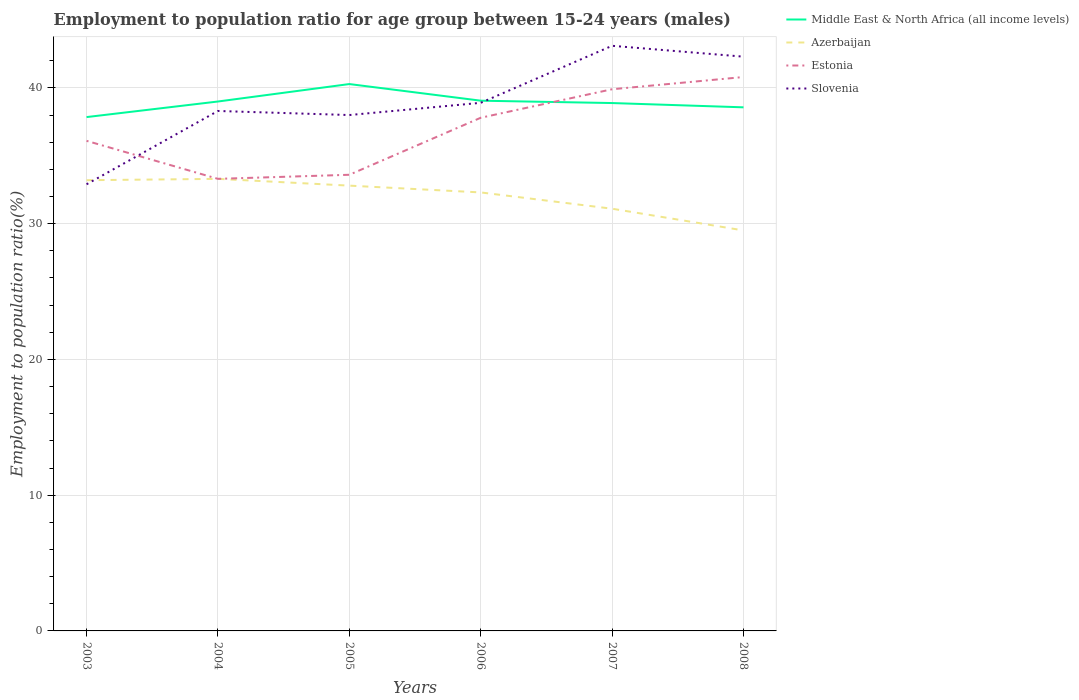Does the line corresponding to Azerbaijan intersect with the line corresponding to Slovenia?
Your answer should be very brief. Yes. Is the number of lines equal to the number of legend labels?
Your response must be concise. Yes. Across all years, what is the maximum employment to population ratio in Azerbaijan?
Your response must be concise. 29.5. In which year was the employment to population ratio in Slovenia maximum?
Ensure brevity in your answer.  2003. What is the total employment to population ratio in Slovenia in the graph?
Keep it short and to the point. -6. What is the difference between the highest and the second highest employment to population ratio in Estonia?
Your response must be concise. 7.5. What is the difference between the highest and the lowest employment to population ratio in Slovenia?
Give a very brief answer. 2. How many lines are there?
Provide a short and direct response. 4. How many years are there in the graph?
Your answer should be very brief. 6. What is the difference between two consecutive major ticks on the Y-axis?
Offer a terse response. 10. How are the legend labels stacked?
Make the answer very short. Vertical. What is the title of the graph?
Offer a very short reply. Employment to population ratio for age group between 15-24 years (males). What is the label or title of the X-axis?
Provide a succinct answer. Years. What is the label or title of the Y-axis?
Ensure brevity in your answer.  Employment to population ratio(%). What is the Employment to population ratio(%) in Middle East & North Africa (all income levels) in 2003?
Offer a very short reply. 37.85. What is the Employment to population ratio(%) of Azerbaijan in 2003?
Offer a terse response. 33.2. What is the Employment to population ratio(%) of Estonia in 2003?
Offer a terse response. 36.1. What is the Employment to population ratio(%) of Slovenia in 2003?
Offer a terse response. 32.9. What is the Employment to population ratio(%) of Middle East & North Africa (all income levels) in 2004?
Provide a succinct answer. 39. What is the Employment to population ratio(%) of Azerbaijan in 2004?
Provide a short and direct response. 33.3. What is the Employment to population ratio(%) in Estonia in 2004?
Offer a very short reply. 33.3. What is the Employment to population ratio(%) of Slovenia in 2004?
Provide a short and direct response. 38.3. What is the Employment to population ratio(%) in Middle East & North Africa (all income levels) in 2005?
Ensure brevity in your answer.  40.28. What is the Employment to population ratio(%) in Azerbaijan in 2005?
Keep it short and to the point. 32.8. What is the Employment to population ratio(%) in Estonia in 2005?
Your answer should be very brief. 33.6. What is the Employment to population ratio(%) in Middle East & North Africa (all income levels) in 2006?
Keep it short and to the point. 39.06. What is the Employment to population ratio(%) of Azerbaijan in 2006?
Ensure brevity in your answer.  32.3. What is the Employment to population ratio(%) in Estonia in 2006?
Give a very brief answer. 37.8. What is the Employment to population ratio(%) of Slovenia in 2006?
Offer a very short reply. 38.9. What is the Employment to population ratio(%) of Middle East & North Africa (all income levels) in 2007?
Your answer should be compact. 38.88. What is the Employment to population ratio(%) in Azerbaijan in 2007?
Provide a succinct answer. 31.1. What is the Employment to population ratio(%) in Estonia in 2007?
Make the answer very short. 39.9. What is the Employment to population ratio(%) of Slovenia in 2007?
Keep it short and to the point. 43.1. What is the Employment to population ratio(%) of Middle East & North Africa (all income levels) in 2008?
Your answer should be very brief. 38.57. What is the Employment to population ratio(%) in Azerbaijan in 2008?
Give a very brief answer. 29.5. What is the Employment to population ratio(%) in Estonia in 2008?
Give a very brief answer. 40.8. What is the Employment to population ratio(%) in Slovenia in 2008?
Your answer should be very brief. 42.3. Across all years, what is the maximum Employment to population ratio(%) in Middle East & North Africa (all income levels)?
Offer a very short reply. 40.28. Across all years, what is the maximum Employment to population ratio(%) of Azerbaijan?
Offer a very short reply. 33.3. Across all years, what is the maximum Employment to population ratio(%) of Estonia?
Your answer should be compact. 40.8. Across all years, what is the maximum Employment to population ratio(%) in Slovenia?
Keep it short and to the point. 43.1. Across all years, what is the minimum Employment to population ratio(%) in Middle East & North Africa (all income levels)?
Your answer should be compact. 37.85. Across all years, what is the minimum Employment to population ratio(%) of Azerbaijan?
Your response must be concise. 29.5. Across all years, what is the minimum Employment to population ratio(%) of Estonia?
Provide a succinct answer. 33.3. Across all years, what is the minimum Employment to population ratio(%) in Slovenia?
Make the answer very short. 32.9. What is the total Employment to population ratio(%) of Middle East & North Africa (all income levels) in the graph?
Your answer should be compact. 233.64. What is the total Employment to population ratio(%) of Azerbaijan in the graph?
Offer a very short reply. 192.2. What is the total Employment to population ratio(%) in Estonia in the graph?
Your answer should be very brief. 221.5. What is the total Employment to population ratio(%) of Slovenia in the graph?
Provide a short and direct response. 233.5. What is the difference between the Employment to population ratio(%) in Middle East & North Africa (all income levels) in 2003 and that in 2004?
Your response must be concise. -1.15. What is the difference between the Employment to population ratio(%) in Azerbaijan in 2003 and that in 2004?
Provide a succinct answer. -0.1. What is the difference between the Employment to population ratio(%) of Estonia in 2003 and that in 2004?
Your answer should be very brief. 2.8. What is the difference between the Employment to population ratio(%) in Slovenia in 2003 and that in 2004?
Your answer should be compact. -5.4. What is the difference between the Employment to population ratio(%) in Middle East & North Africa (all income levels) in 2003 and that in 2005?
Your answer should be compact. -2.43. What is the difference between the Employment to population ratio(%) of Azerbaijan in 2003 and that in 2005?
Make the answer very short. 0.4. What is the difference between the Employment to population ratio(%) of Middle East & North Africa (all income levels) in 2003 and that in 2006?
Give a very brief answer. -1.21. What is the difference between the Employment to population ratio(%) in Estonia in 2003 and that in 2006?
Provide a short and direct response. -1.7. What is the difference between the Employment to population ratio(%) of Slovenia in 2003 and that in 2006?
Your answer should be compact. -6. What is the difference between the Employment to population ratio(%) of Middle East & North Africa (all income levels) in 2003 and that in 2007?
Keep it short and to the point. -1.03. What is the difference between the Employment to population ratio(%) in Estonia in 2003 and that in 2007?
Make the answer very short. -3.8. What is the difference between the Employment to population ratio(%) of Slovenia in 2003 and that in 2007?
Your answer should be very brief. -10.2. What is the difference between the Employment to population ratio(%) in Middle East & North Africa (all income levels) in 2003 and that in 2008?
Offer a terse response. -0.72. What is the difference between the Employment to population ratio(%) of Estonia in 2003 and that in 2008?
Make the answer very short. -4.7. What is the difference between the Employment to population ratio(%) of Slovenia in 2003 and that in 2008?
Offer a very short reply. -9.4. What is the difference between the Employment to population ratio(%) in Middle East & North Africa (all income levels) in 2004 and that in 2005?
Provide a succinct answer. -1.29. What is the difference between the Employment to population ratio(%) in Middle East & North Africa (all income levels) in 2004 and that in 2006?
Ensure brevity in your answer.  -0.06. What is the difference between the Employment to population ratio(%) in Azerbaijan in 2004 and that in 2006?
Keep it short and to the point. 1. What is the difference between the Employment to population ratio(%) in Slovenia in 2004 and that in 2006?
Keep it short and to the point. -0.6. What is the difference between the Employment to population ratio(%) in Middle East & North Africa (all income levels) in 2004 and that in 2007?
Offer a very short reply. 0.11. What is the difference between the Employment to population ratio(%) in Azerbaijan in 2004 and that in 2007?
Your answer should be compact. 2.2. What is the difference between the Employment to population ratio(%) in Estonia in 2004 and that in 2007?
Your answer should be very brief. -6.6. What is the difference between the Employment to population ratio(%) in Middle East & North Africa (all income levels) in 2004 and that in 2008?
Ensure brevity in your answer.  0.43. What is the difference between the Employment to population ratio(%) of Estonia in 2004 and that in 2008?
Offer a terse response. -7.5. What is the difference between the Employment to population ratio(%) of Slovenia in 2004 and that in 2008?
Give a very brief answer. -4. What is the difference between the Employment to population ratio(%) in Middle East & North Africa (all income levels) in 2005 and that in 2006?
Give a very brief answer. 1.23. What is the difference between the Employment to population ratio(%) of Azerbaijan in 2005 and that in 2006?
Offer a terse response. 0.5. What is the difference between the Employment to population ratio(%) of Slovenia in 2005 and that in 2006?
Offer a terse response. -0.9. What is the difference between the Employment to population ratio(%) of Middle East & North Africa (all income levels) in 2005 and that in 2007?
Give a very brief answer. 1.4. What is the difference between the Employment to population ratio(%) in Azerbaijan in 2005 and that in 2007?
Ensure brevity in your answer.  1.7. What is the difference between the Employment to population ratio(%) of Slovenia in 2005 and that in 2007?
Ensure brevity in your answer.  -5.1. What is the difference between the Employment to population ratio(%) in Middle East & North Africa (all income levels) in 2005 and that in 2008?
Your response must be concise. 1.72. What is the difference between the Employment to population ratio(%) in Azerbaijan in 2005 and that in 2008?
Keep it short and to the point. 3.3. What is the difference between the Employment to population ratio(%) in Estonia in 2005 and that in 2008?
Provide a succinct answer. -7.2. What is the difference between the Employment to population ratio(%) of Slovenia in 2005 and that in 2008?
Give a very brief answer. -4.3. What is the difference between the Employment to population ratio(%) in Middle East & North Africa (all income levels) in 2006 and that in 2007?
Provide a succinct answer. 0.17. What is the difference between the Employment to population ratio(%) of Azerbaijan in 2006 and that in 2007?
Give a very brief answer. 1.2. What is the difference between the Employment to population ratio(%) of Estonia in 2006 and that in 2007?
Offer a very short reply. -2.1. What is the difference between the Employment to population ratio(%) of Slovenia in 2006 and that in 2007?
Offer a very short reply. -4.2. What is the difference between the Employment to population ratio(%) of Middle East & North Africa (all income levels) in 2006 and that in 2008?
Make the answer very short. 0.49. What is the difference between the Employment to population ratio(%) in Azerbaijan in 2006 and that in 2008?
Offer a very short reply. 2.8. What is the difference between the Employment to population ratio(%) in Middle East & North Africa (all income levels) in 2007 and that in 2008?
Your response must be concise. 0.32. What is the difference between the Employment to population ratio(%) in Azerbaijan in 2007 and that in 2008?
Provide a short and direct response. 1.6. What is the difference between the Employment to population ratio(%) of Estonia in 2007 and that in 2008?
Your answer should be very brief. -0.9. What is the difference between the Employment to population ratio(%) in Middle East & North Africa (all income levels) in 2003 and the Employment to population ratio(%) in Azerbaijan in 2004?
Keep it short and to the point. 4.55. What is the difference between the Employment to population ratio(%) of Middle East & North Africa (all income levels) in 2003 and the Employment to population ratio(%) of Estonia in 2004?
Your answer should be compact. 4.55. What is the difference between the Employment to population ratio(%) in Middle East & North Africa (all income levels) in 2003 and the Employment to population ratio(%) in Slovenia in 2004?
Make the answer very short. -0.45. What is the difference between the Employment to population ratio(%) in Azerbaijan in 2003 and the Employment to population ratio(%) in Estonia in 2004?
Offer a terse response. -0.1. What is the difference between the Employment to population ratio(%) in Estonia in 2003 and the Employment to population ratio(%) in Slovenia in 2004?
Provide a succinct answer. -2.2. What is the difference between the Employment to population ratio(%) in Middle East & North Africa (all income levels) in 2003 and the Employment to population ratio(%) in Azerbaijan in 2005?
Make the answer very short. 5.05. What is the difference between the Employment to population ratio(%) in Middle East & North Africa (all income levels) in 2003 and the Employment to population ratio(%) in Estonia in 2005?
Provide a succinct answer. 4.25. What is the difference between the Employment to population ratio(%) of Middle East & North Africa (all income levels) in 2003 and the Employment to population ratio(%) of Slovenia in 2005?
Make the answer very short. -0.15. What is the difference between the Employment to population ratio(%) of Azerbaijan in 2003 and the Employment to population ratio(%) of Slovenia in 2005?
Provide a short and direct response. -4.8. What is the difference between the Employment to population ratio(%) of Estonia in 2003 and the Employment to population ratio(%) of Slovenia in 2005?
Keep it short and to the point. -1.9. What is the difference between the Employment to population ratio(%) in Middle East & North Africa (all income levels) in 2003 and the Employment to population ratio(%) in Azerbaijan in 2006?
Your response must be concise. 5.55. What is the difference between the Employment to population ratio(%) in Middle East & North Africa (all income levels) in 2003 and the Employment to population ratio(%) in Estonia in 2006?
Give a very brief answer. 0.05. What is the difference between the Employment to population ratio(%) of Middle East & North Africa (all income levels) in 2003 and the Employment to population ratio(%) of Slovenia in 2006?
Offer a very short reply. -1.05. What is the difference between the Employment to population ratio(%) of Azerbaijan in 2003 and the Employment to population ratio(%) of Estonia in 2006?
Give a very brief answer. -4.6. What is the difference between the Employment to population ratio(%) in Azerbaijan in 2003 and the Employment to population ratio(%) in Slovenia in 2006?
Your answer should be very brief. -5.7. What is the difference between the Employment to population ratio(%) in Estonia in 2003 and the Employment to population ratio(%) in Slovenia in 2006?
Give a very brief answer. -2.8. What is the difference between the Employment to population ratio(%) in Middle East & North Africa (all income levels) in 2003 and the Employment to population ratio(%) in Azerbaijan in 2007?
Ensure brevity in your answer.  6.75. What is the difference between the Employment to population ratio(%) of Middle East & North Africa (all income levels) in 2003 and the Employment to population ratio(%) of Estonia in 2007?
Provide a short and direct response. -2.05. What is the difference between the Employment to population ratio(%) in Middle East & North Africa (all income levels) in 2003 and the Employment to population ratio(%) in Slovenia in 2007?
Your response must be concise. -5.25. What is the difference between the Employment to population ratio(%) in Middle East & North Africa (all income levels) in 2003 and the Employment to population ratio(%) in Azerbaijan in 2008?
Your answer should be very brief. 8.35. What is the difference between the Employment to population ratio(%) of Middle East & North Africa (all income levels) in 2003 and the Employment to population ratio(%) of Estonia in 2008?
Your answer should be compact. -2.95. What is the difference between the Employment to population ratio(%) of Middle East & North Africa (all income levels) in 2003 and the Employment to population ratio(%) of Slovenia in 2008?
Your response must be concise. -4.45. What is the difference between the Employment to population ratio(%) of Azerbaijan in 2003 and the Employment to population ratio(%) of Estonia in 2008?
Ensure brevity in your answer.  -7.6. What is the difference between the Employment to population ratio(%) in Middle East & North Africa (all income levels) in 2004 and the Employment to population ratio(%) in Azerbaijan in 2005?
Make the answer very short. 6.2. What is the difference between the Employment to population ratio(%) in Middle East & North Africa (all income levels) in 2004 and the Employment to population ratio(%) in Estonia in 2005?
Provide a succinct answer. 5.4. What is the difference between the Employment to population ratio(%) of Middle East & North Africa (all income levels) in 2004 and the Employment to population ratio(%) of Slovenia in 2005?
Keep it short and to the point. 1. What is the difference between the Employment to population ratio(%) of Azerbaijan in 2004 and the Employment to population ratio(%) of Slovenia in 2005?
Offer a very short reply. -4.7. What is the difference between the Employment to population ratio(%) of Estonia in 2004 and the Employment to population ratio(%) of Slovenia in 2005?
Make the answer very short. -4.7. What is the difference between the Employment to population ratio(%) in Middle East & North Africa (all income levels) in 2004 and the Employment to population ratio(%) in Azerbaijan in 2006?
Give a very brief answer. 6.7. What is the difference between the Employment to population ratio(%) of Middle East & North Africa (all income levels) in 2004 and the Employment to population ratio(%) of Estonia in 2006?
Your answer should be very brief. 1.2. What is the difference between the Employment to population ratio(%) of Middle East & North Africa (all income levels) in 2004 and the Employment to population ratio(%) of Slovenia in 2006?
Ensure brevity in your answer.  0.1. What is the difference between the Employment to population ratio(%) in Azerbaijan in 2004 and the Employment to population ratio(%) in Estonia in 2006?
Ensure brevity in your answer.  -4.5. What is the difference between the Employment to population ratio(%) of Azerbaijan in 2004 and the Employment to population ratio(%) of Slovenia in 2006?
Provide a succinct answer. -5.6. What is the difference between the Employment to population ratio(%) in Middle East & North Africa (all income levels) in 2004 and the Employment to population ratio(%) in Azerbaijan in 2007?
Ensure brevity in your answer.  7.9. What is the difference between the Employment to population ratio(%) of Middle East & North Africa (all income levels) in 2004 and the Employment to population ratio(%) of Estonia in 2007?
Keep it short and to the point. -0.9. What is the difference between the Employment to population ratio(%) in Middle East & North Africa (all income levels) in 2004 and the Employment to population ratio(%) in Slovenia in 2007?
Give a very brief answer. -4.1. What is the difference between the Employment to population ratio(%) of Azerbaijan in 2004 and the Employment to population ratio(%) of Estonia in 2007?
Make the answer very short. -6.6. What is the difference between the Employment to population ratio(%) of Estonia in 2004 and the Employment to population ratio(%) of Slovenia in 2007?
Your response must be concise. -9.8. What is the difference between the Employment to population ratio(%) in Middle East & North Africa (all income levels) in 2004 and the Employment to population ratio(%) in Azerbaijan in 2008?
Your response must be concise. 9.5. What is the difference between the Employment to population ratio(%) in Middle East & North Africa (all income levels) in 2004 and the Employment to population ratio(%) in Estonia in 2008?
Give a very brief answer. -1.8. What is the difference between the Employment to population ratio(%) of Middle East & North Africa (all income levels) in 2004 and the Employment to population ratio(%) of Slovenia in 2008?
Your answer should be compact. -3.3. What is the difference between the Employment to population ratio(%) of Azerbaijan in 2004 and the Employment to population ratio(%) of Slovenia in 2008?
Make the answer very short. -9. What is the difference between the Employment to population ratio(%) of Middle East & North Africa (all income levels) in 2005 and the Employment to population ratio(%) of Azerbaijan in 2006?
Make the answer very short. 7.98. What is the difference between the Employment to population ratio(%) of Middle East & North Africa (all income levels) in 2005 and the Employment to population ratio(%) of Estonia in 2006?
Provide a succinct answer. 2.48. What is the difference between the Employment to population ratio(%) in Middle East & North Africa (all income levels) in 2005 and the Employment to population ratio(%) in Slovenia in 2006?
Provide a succinct answer. 1.38. What is the difference between the Employment to population ratio(%) of Azerbaijan in 2005 and the Employment to population ratio(%) of Estonia in 2006?
Your answer should be compact. -5. What is the difference between the Employment to population ratio(%) in Estonia in 2005 and the Employment to population ratio(%) in Slovenia in 2006?
Your response must be concise. -5.3. What is the difference between the Employment to population ratio(%) of Middle East & North Africa (all income levels) in 2005 and the Employment to population ratio(%) of Azerbaijan in 2007?
Provide a short and direct response. 9.18. What is the difference between the Employment to population ratio(%) of Middle East & North Africa (all income levels) in 2005 and the Employment to population ratio(%) of Estonia in 2007?
Provide a succinct answer. 0.38. What is the difference between the Employment to population ratio(%) of Middle East & North Africa (all income levels) in 2005 and the Employment to population ratio(%) of Slovenia in 2007?
Your answer should be very brief. -2.82. What is the difference between the Employment to population ratio(%) in Middle East & North Africa (all income levels) in 2005 and the Employment to population ratio(%) in Azerbaijan in 2008?
Make the answer very short. 10.78. What is the difference between the Employment to population ratio(%) of Middle East & North Africa (all income levels) in 2005 and the Employment to population ratio(%) of Estonia in 2008?
Your answer should be very brief. -0.52. What is the difference between the Employment to population ratio(%) of Middle East & North Africa (all income levels) in 2005 and the Employment to population ratio(%) of Slovenia in 2008?
Your answer should be compact. -2.02. What is the difference between the Employment to population ratio(%) in Middle East & North Africa (all income levels) in 2006 and the Employment to population ratio(%) in Azerbaijan in 2007?
Offer a very short reply. 7.96. What is the difference between the Employment to population ratio(%) in Middle East & North Africa (all income levels) in 2006 and the Employment to population ratio(%) in Estonia in 2007?
Your answer should be very brief. -0.84. What is the difference between the Employment to population ratio(%) in Middle East & North Africa (all income levels) in 2006 and the Employment to population ratio(%) in Slovenia in 2007?
Give a very brief answer. -4.04. What is the difference between the Employment to population ratio(%) of Azerbaijan in 2006 and the Employment to population ratio(%) of Estonia in 2007?
Keep it short and to the point. -7.6. What is the difference between the Employment to population ratio(%) of Estonia in 2006 and the Employment to population ratio(%) of Slovenia in 2007?
Ensure brevity in your answer.  -5.3. What is the difference between the Employment to population ratio(%) in Middle East & North Africa (all income levels) in 2006 and the Employment to population ratio(%) in Azerbaijan in 2008?
Your answer should be compact. 9.56. What is the difference between the Employment to population ratio(%) of Middle East & North Africa (all income levels) in 2006 and the Employment to population ratio(%) of Estonia in 2008?
Offer a terse response. -1.74. What is the difference between the Employment to population ratio(%) of Middle East & North Africa (all income levels) in 2006 and the Employment to population ratio(%) of Slovenia in 2008?
Offer a very short reply. -3.24. What is the difference between the Employment to population ratio(%) of Azerbaijan in 2006 and the Employment to population ratio(%) of Estonia in 2008?
Offer a terse response. -8.5. What is the difference between the Employment to population ratio(%) in Middle East & North Africa (all income levels) in 2007 and the Employment to population ratio(%) in Azerbaijan in 2008?
Your answer should be very brief. 9.38. What is the difference between the Employment to population ratio(%) in Middle East & North Africa (all income levels) in 2007 and the Employment to population ratio(%) in Estonia in 2008?
Ensure brevity in your answer.  -1.92. What is the difference between the Employment to population ratio(%) of Middle East & North Africa (all income levels) in 2007 and the Employment to population ratio(%) of Slovenia in 2008?
Provide a short and direct response. -3.42. What is the average Employment to population ratio(%) of Middle East & North Africa (all income levels) per year?
Keep it short and to the point. 38.94. What is the average Employment to population ratio(%) in Azerbaijan per year?
Give a very brief answer. 32.03. What is the average Employment to population ratio(%) of Estonia per year?
Keep it short and to the point. 36.92. What is the average Employment to population ratio(%) of Slovenia per year?
Provide a short and direct response. 38.92. In the year 2003, what is the difference between the Employment to population ratio(%) in Middle East & North Africa (all income levels) and Employment to population ratio(%) in Azerbaijan?
Offer a very short reply. 4.65. In the year 2003, what is the difference between the Employment to population ratio(%) in Middle East & North Africa (all income levels) and Employment to population ratio(%) in Estonia?
Offer a terse response. 1.75. In the year 2003, what is the difference between the Employment to population ratio(%) of Middle East & North Africa (all income levels) and Employment to population ratio(%) of Slovenia?
Your answer should be very brief. 4.95. In the year 2004, what is the difference between the Employment to population ratio(%) of Middle East & North Africa (all income levels) and Employment to population ratio(%) of Azerbaijan?
Offer a very short reply. 5.7. In the year 2004, what is the difference between the Employment to population ratio(%) in Middle East & North Africa (all income levels) and Employment to population ratio(%) in Estonia?
Your answer should be very brief. 5.7. In the year 2004, what is the difference between the Employment to population ratio(%) of Middle East & North Africa (all income levels) and Employment to population ratio(%) of Slovenia?
Your answer should be compact. 0.7. In the year 2004, what is the difference between the Employment to population ratio(%) in Azerbaijan and Employment to population ratio(%) in Estonia?
Provide a succinct answer. 0. In the year 2004, what is the difference between the Employment to population ratio(%) in Azerbaijan and Employment to population ratio(%) in Slovenia?
Offer a terse response. -5. In the year 2005, what is the difference between the Employment to population ratio(%) in Middle East & North Africa (all income levels) and Employment to population ratio(%) in Azerbaijan?
Your answer should be very brief. 7.48. In the year 2005, what is the difference between the Employment to population ratio(%) of Middle East & North Africa (all income levels) and Employment to population ratio(%) of Estonia?
Make the answer very short. 6.68. In the year 2005, what is the difference between the Employment to population ratio(%) in Middle East & North Africa (all income levels) and Employment to population ratio(%) in Slovenia?
Offer a terse response. 2.28. In the year 2005, what is the difference between the Employment to population ratio(%) in Azerbaijan and Employment to population ratio(%) in Slovenia?
Give a very brief answer. -5.2. In the year 2006, what is the difference between the Employment to population ratio(%) in Middle East & North Africa (all income levels) and Employment to population ratio(%) in Azerbaijan?
Keep it short and to the point. 6.76. In the year 2006, what is the difference between the Employment to population ratio(%) in Middle East & North Africa (all income levels) and Employment to population ratio(%) in Estonia?
Keep it short and to the point. 1.26. In the year 2006, what is the difference between the Employment to population ratio(%) of Middle East & North Africa (all income levels) and Employment to population ratio(%) of Slovenia?
Provide a succinct answer. 0.16. In the year 2006, what is the difference between the Employment to population ratio(%) in Azerbaijan and Employment to population ratio(%) in Estonia?
Offer a terse response. -5.5. In the year 2006, what is the difference between the Employment to population ratio(%) of Estonia and Employment to population ratio(%) of Slovenia?
Make the answer very short. -1.1. In the year 2007, what is the difference between the Employment to population ratio(%) in Middle East & North Africa (all income levels) and Employment to population ratio(%) in Azerbaijan?
Ensure brevity in your answer.  7.78. In the year 2007, what is the difference between the Employment to population ratio(%) in Middle East & North Africa (all income levels) and Employment to population ratio(%) in Estonia?
Provide a short and direct response. -1.02. In the year 2007, what is the difference between the Employment to population ratio(%) of Middle East & North Africa (all income levels) and Employment to population ratio(%) of Slovenia?
Give a very brief answer. -4.22. In the year 2007, what is the difference between the Employment to population ratio(%) in Azerbaijan and Employment to population ratio(%) in Estonia?
Provide a short and direct response. -8.8. In the year 2007, what is the difference between the Employment to population ratio(%) in Azerbaijan and Employment to population ratio(%) in Slovenia?
Your response must be concise. -12. In the year 2008, what is the difference between the Employment to population ratio(%) of Middle East & North Africa (all income levels) and Employment to population ratio(%) of Azerbaijan?
Your answer should be compact. 9.07. In the year 2008, what is the difference between the Employment to population ratio(%) in Middle East & North Africa (all income levels) and Employment to population ratio(%) in Estonia?
Provide a short and direct response. -2.23. In the year 2008, what is the difference between the Employment to population ratio(%) of Middle East & North Africa (all income levels) and Employment to population ratio(%) of Slovenia?
Your response must be concise. -3.73. In the year 2008, what is the difference between the Employment to population ratio(%) of Azerbaijan and Employment to population ratio(%) of Estonia?
Offer a terse response. -11.3. In the year 2008, what is the difference between the Employment to population ratio(%) of Estonia and Employment to population ratio(%) of Slovenia?
Ensure brevity in your answer.  -1.5. What is the ratio of the Employment to population ratio(%) of Middle East & North Africa (all income levels) in 2003 to that in 2004?
Your response must be concise. 0.97. What is the ratio of the Employment to population ratio(%) of Estonia in 2003 to that in 2004?
Offer a very short reply. 1.08. What is the ratio of the Employment to population ratio(%) in Slovenia in 2003 to that in 2004?
Offer a terse response. 0.86. What is the ratio of the Employment to population ratio(%) of Middle East & North Africa (all income levels) in 2003 to that in 2005?
Offer a terse response. 0.94. What is the ratio of the Employment to population ratio(%) of Azerbaijan in 2003 to that in 2005?
Offer a very short reply. 1.01. What is the ratio of the Employment to population ratio(%) in Estonia in 2003 to that in 2005?
Your answer should be very brief. 1.07. What is the ratio of the Employment to population ratio(%) of Slovenia in 2003 to that in 2005?
Make the answer very short. 0.87. What is the ratio of the Employment to population ratio(%) of Middle East & North Africa (all income levels) in 2003 to that in 2006?
Keep it short and to the point. 0.97. What is the ratio of the Employment to population ratio(%) in Azerbaijan in 2003 to that in 2006?
Keep it short and to the point. 1.03. What is the ratio of the Employment to population ratio(%) of Estonia in 2003 to that in 2006?
Offer a terse response. 0.95. What is the ratio of the Employment to population ratio(%) of Slovenia in 2003 to that in 2006?
Keep it short and to the point. 0.85. What is the ratio of the Employment to population ratio(%) of Middle East & North Africa (all income levels) in 2003 to that in 2007?
Offer a very short reply. 0.97. What is the ratio of the Employment to population ratio(%) in Azerbaijan in 2003 to that in 2007?
Ensure brevity in your answer.  1.07. What is the ratio of the Employment to population ratio(%) in Estonia in 2003 to that in 2007?
Your answer should be compact. 0.9. What is the ratio of the Employment to population ratio(%) in Slovenia in 2003 to that in 2007?
Provide a succinct answer. 0.76. What is the ratio of the Employment to population ratio(%) in Middle East & North Africa (all income levels) in 2003 to that in 2008?
Offer a very short reply. 0.98. What is the ratio of the Employment to population ratio(%) in Azerbaijan in 2003 to that in 2008?
Offer a terse response. 1.13. What is the ratio of the Employment to population ratio(%) of Estonia in 2003 to that in 2008?
Your answer should be very brief. 0.88. What is the ratio of the Employment to population ratio(%) of Middle East & North Africa (all income levels) in 2004 to that in 2005?
Your answer should be very brief. 0.97. What is the ratio of the Employment to population ratio(%) of Azerbaijan in 2004 to that in 2005?
Make the answer very short. 1.02. What is the ratio of the Employment to population ratio(%) in Estonia in 2004 to that in 2005?
Provide a succinct answer. 0.99. What is the ratio of the Employment to population ratio(%) of Slovenia in 2004 to that in 2005?
Provide a short and direct response. 1.01. What is the ratio of the Employment to population ratio(%) of Azerbaijan in 2004 to that in 2006?
Make the answer very short. 1.03. What is the ratio of the Employment to population ratio(%) of Estonia in 2004 to that in 2006?
Offer a very short reply. 0.88. What is the ratio of the Employment to population ratio(%) in Slovenia in 2004 to that in 2006?
Your answer should be very brief. 0.98. What is the ratio of the Employment to population ratio(%) in Azerbaijan in 2004 to that in 2007?
Provide a short and direct response. 1.07. What is the ratio of the Employment to population ratio(%) of Estonia in 2004 to that in 2007?
Offer a very short reply. 0.83. What is the ratio of the Employment to population ratio(%) of Slovenia in 2004 to that in 2007?
Offer a terse response. 0.89. What is the ratio of the Employment to population ratio(%) in Middle East & North Africa (all income levels) in 2004 to that in 2008?
Offer a terse response. 1.01. What is the ratio of the Employment to population ratio(%) of Azerbaijan in 2004 to that in 2008?
Your response must be concise. 1.13. What is the ratio of the Employment to population ratio(%) in Estonia in 2004 to that in 2008?
Offer a terse response. 0.82. What is the ratio of the Employment to population ratio(%) of Slovenia in 2004 to that in 2008?
Your answer should be very brief. 0.91. What is the ratio of the Employment to population ratio(%) of Middle East & North Africa (all income levels) in 2005 to that in 2006?
Your answer should be very brief. 1.03. What is the ratio of the Employment to population ratio(%) of Azerbaijan in 2005 to that in 2006?
Offer a terse response. 1.02. What is the ratio of the Employment to population ratio(%) in Estonia in 2005 to that in 2006?
Offer a terse response. 0.89. What is the ratio of the Employment to population ratio(%) in Slovenia in 2005 to that in 2006?
Provide a succinct answer. 0.98. What is the ratio of the Employment to population ratio(%) in Middle East & North Africa (all income levels) in 2005 to that in 2007?
Ensure brevity in your answer.  1.04. What is the ratio of the Employment to population ratio(%) of Azerbaijan in 2005 to that in 2007?
Offer a very short reply. 1.05. What is the ratio of the Employment to population ratio(%) of Estonia in 2005 to that in 2007?
Give a very brief answer. 0.84. What is the ratio of the Employment to population ratio(%) in Slovenia in 2005 to that in 2007?
Your answer should be very brief. 0.88. What is the ratio of the Employment to population ratio(%) of Middle East & North Africa (all income levels) in 2005 to that in 2008?
Your answer should be compact. 1.04. What is the ratio of the Employment to population ratio(%) of Azerbaijan in 2005 to that in 2008?
Your answer should be very brief. 1.11. What is the ratio of the Employment to population ratio(%) of Estonia in 2005 to that in 2008?
Ensure brevity in your answer.  0.82. What is the ratio of the Employment to population ratio(%) of Slovenia in 2005 to that in 2008?
Your answer should be very brief. 0.9. What is the ratio of the Employment to population ratio(%) in Middle East & North Africa (all income levels) in 2006 to that in 2007?
Offer a terse response. 1. What is the ratio of the Employment to population ratio(%) in Azerbaijan in 2006 to that in 2007?
Keep it short and to the point. 1.04. What is the ratio of the Employment to population ratio(%) in Slovenia in 2006 to that in 2007?
Ensure brevity in your answer.  0.9. What is the ratio of the Employment to population ratio(%) in Middle East & North Africa (all income levels) in 2006 to that in 2008?
Provide a short and direct response. 1.01. What is the ratio of the Employment to population ratio(%) in Azerbaijan in 2006 to that in 2008?
Your answer should be very brief. 1.09. What is the ratio of the Employment to population ratio(%) of Estonia in 2006 to that in 2008?
Your response must be concise. 0.93. What is the ratio of the Employment to population ratio(%) of Slovenia in 2006 to that in 2008?
Ensure brevity in your answer.  0.92. What is the ratio of the Employment to population ratio(%) in Middle East & North Africa (all income levels) in 2007 to that in 2008?
Provide a short and direct response. 1.01. What is the ratio of the Employment to population ratio(%) in Azerbaijan in 2007 to that in 2008?
Your answer should be compact. 1.05. What is the ratio of the Employment to population ratio(%) of Estonia in 2007 to that in 2008?
Provide a short and direct response. 0.98. What is the ratio of the Employment to population ratio(%) of Slovenia in 2007 to that in 2008?
Ensure brevity in your answer.  1.02. What is the difference between the highest and the second highest Employment to population ratio(%) in Middle East & North Africa (all income levels)?
Make the answer very short. 1.23. What is the difference between the highest and the second highest Employment to population ratio(%) of Azerbaijan?
Your answer should be compact. 0.1. What is the difference between the highest and the lowest Employment to population ratio(%) of Middle East & North Africa (all income levels)?
Make the answer very short. 2.43. What is the difference between the highest and the lowest Employment to population ratio(%) of Slovenia?
Your answer should be very brief. 10.2. 